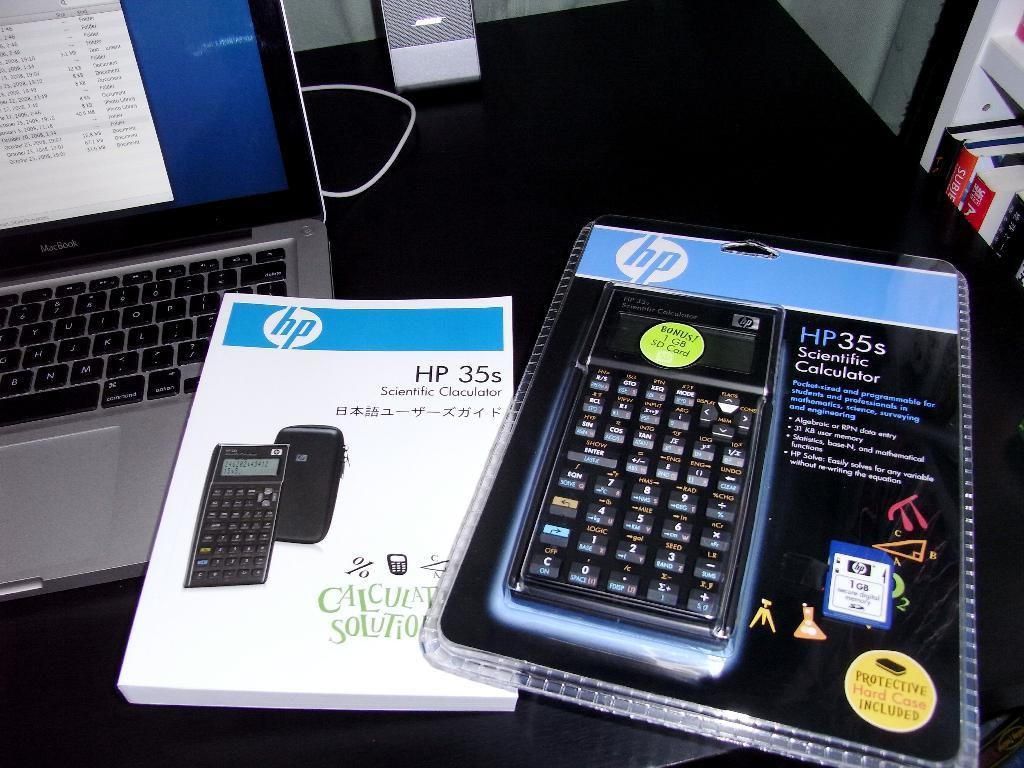<image>
Give a short and clear explanation of the subsequent image. An HP scientific calculator manual beside the unopened package of the HP 35s scientific calculator 